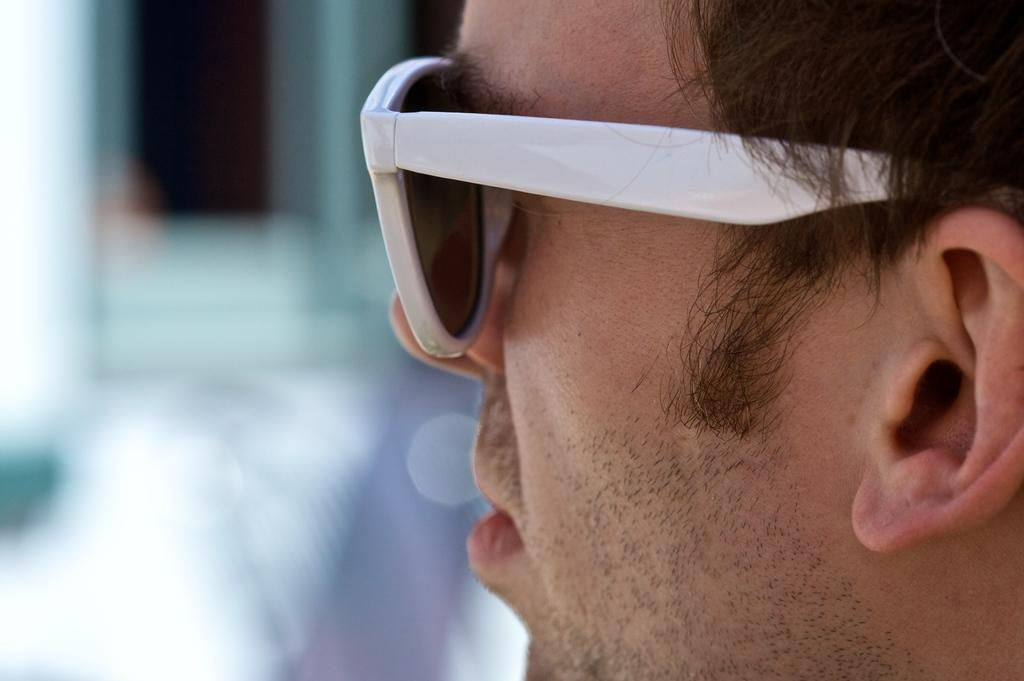What is the main subject of the image? There is a man standing in the image. What can be observed about the man's appearance? The man is wearing spectacles. Can you describe the background of the image? The backdrop of the image is blurred. How many roses can be seen in the man's hand in the image? There are no roses present in the image. Is the man pulling a cart in the image? There is no cart or any indication of pulling in the image. 